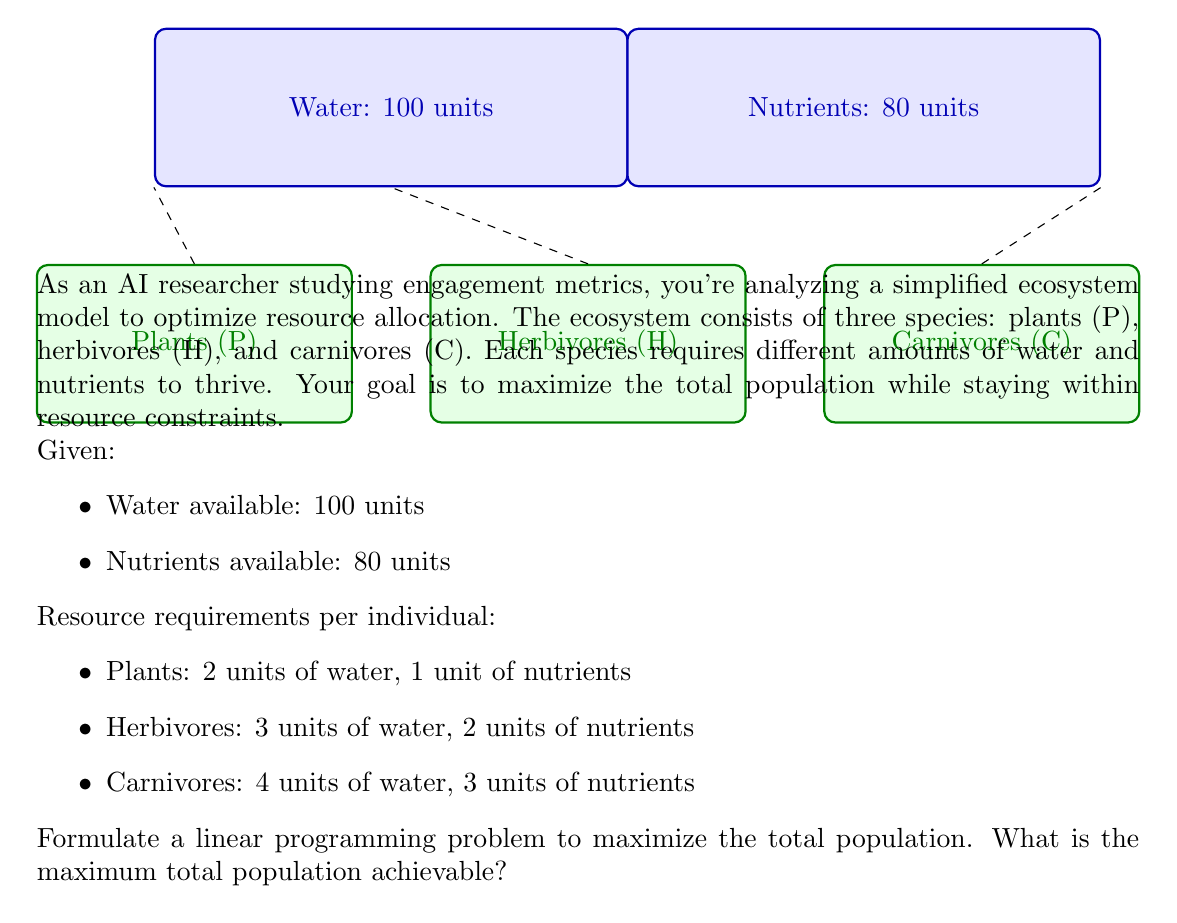Could you help me with this problem? To solve this linear programming problem, we'll follow these steps:

1. Define variables:
   Let $P$, $H$, and $C$ represent the number of plants, herbivores, and carnivores, respectively.

2. Formulate the objective function:
   Maximize $Z = P + H + C$ (total population)

3. Set up constraints:
   a. Water constraint: $2P + 3H + 4C \leq 100$
   b. Nutrient constraint: $P + 2H + 3C \leq 80$
   c. Non-negativity constraints: $P, H, C \geq 0$

4. Solve using the simplex method or linear programming solver:

   We can use the simplex method or a linear programming solver to find the optimal solution. However, for this problem, we can also use a graphical method since we have only two binding constraints.

5. Graphical solution:
   Plot the constraints on a 2D graph, considering two variables at a time:

   a. Water constraint: $2P + 3H = 100$ (when $C = 0$)
   b. Nutrient constraint: $P + 2H = 80$ (when $C = 0$)

   The feasible region is the area bounded by these lines and the non-negativity constraints.

6. Find the corner points of the feasible region:
   (0, 0), (80, 0), (40, 20), (50, 0)

7. Evaluate the objective function at each corner point:
   (0, 0): $Z = 0$
   (80, 0): $Z = 80$
   (40, 20): $Z = 60$
   (50, 0): $Z = 50$

8. The maximum value occurs at the point (40, 20), which represents 40 plants and 20 herbivores.

9. Check if adding carnivores improves the solution:
   Remaining resources: 20 units of water, 20 units of nutrients
   Maximum carnivores: $\min(20/4, 20/3) = 5$

10. Final solution:
    40 plants, 20 herbivores, and 5 carnivores

Therefore, the maximum total population achievable is 40 + 20 + 5 = 65.
Answer: 65 